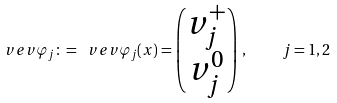Convert formula to latex. <formula><loc_0><loc_0><loc_500><loc_500>\ v e v { \varphi _ { j } } \colon = \ v e v { \varphi _ { j } ( x ) } = \begin{pmatrix} v _ { j } ^ { + } \\ v _ { j } ^ { 0 } \end{pmatrix} \, , \quad j = 1 , 2</formula> 